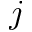<formula> <loc_0><loc_0><loc_500><loc_500>j</formula> 